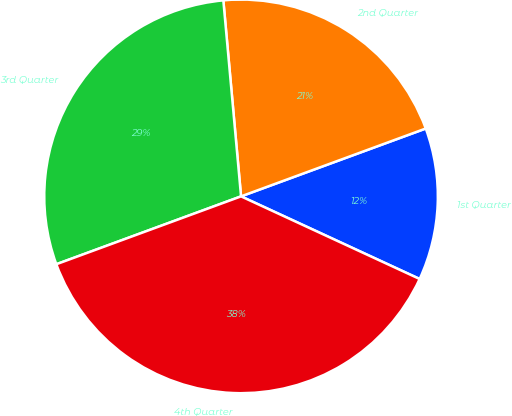Convert chart to OTSL. <chart><loc_0><loc_0><loc_500><loc_500><pie_chart><fcel>1st Quarter<fcel>2nd Quarter<fcel>3rd Quarter<fcel>4th Quarter<nl><fcel>12.5%<fcel>20.83%<fcel>29.17%<fcel>37.5%<nl></chart> 